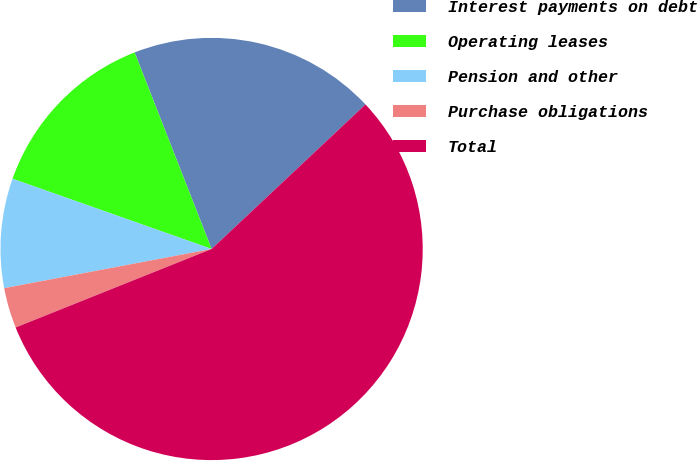Convert chart to OTSL. <chart><loc_0><loc_0><loc_500><loc_500><pie_chart><fcel>Interest payments on debt<fcel>Operating leases<fcel>Pension and other<fcel>Purchase obligations<fcel>Total<nl><fcel>18.94%<fcel>13.66%<fcel>8.37%<fcel>3.09%<fcel>55.94%<nl></chart> 